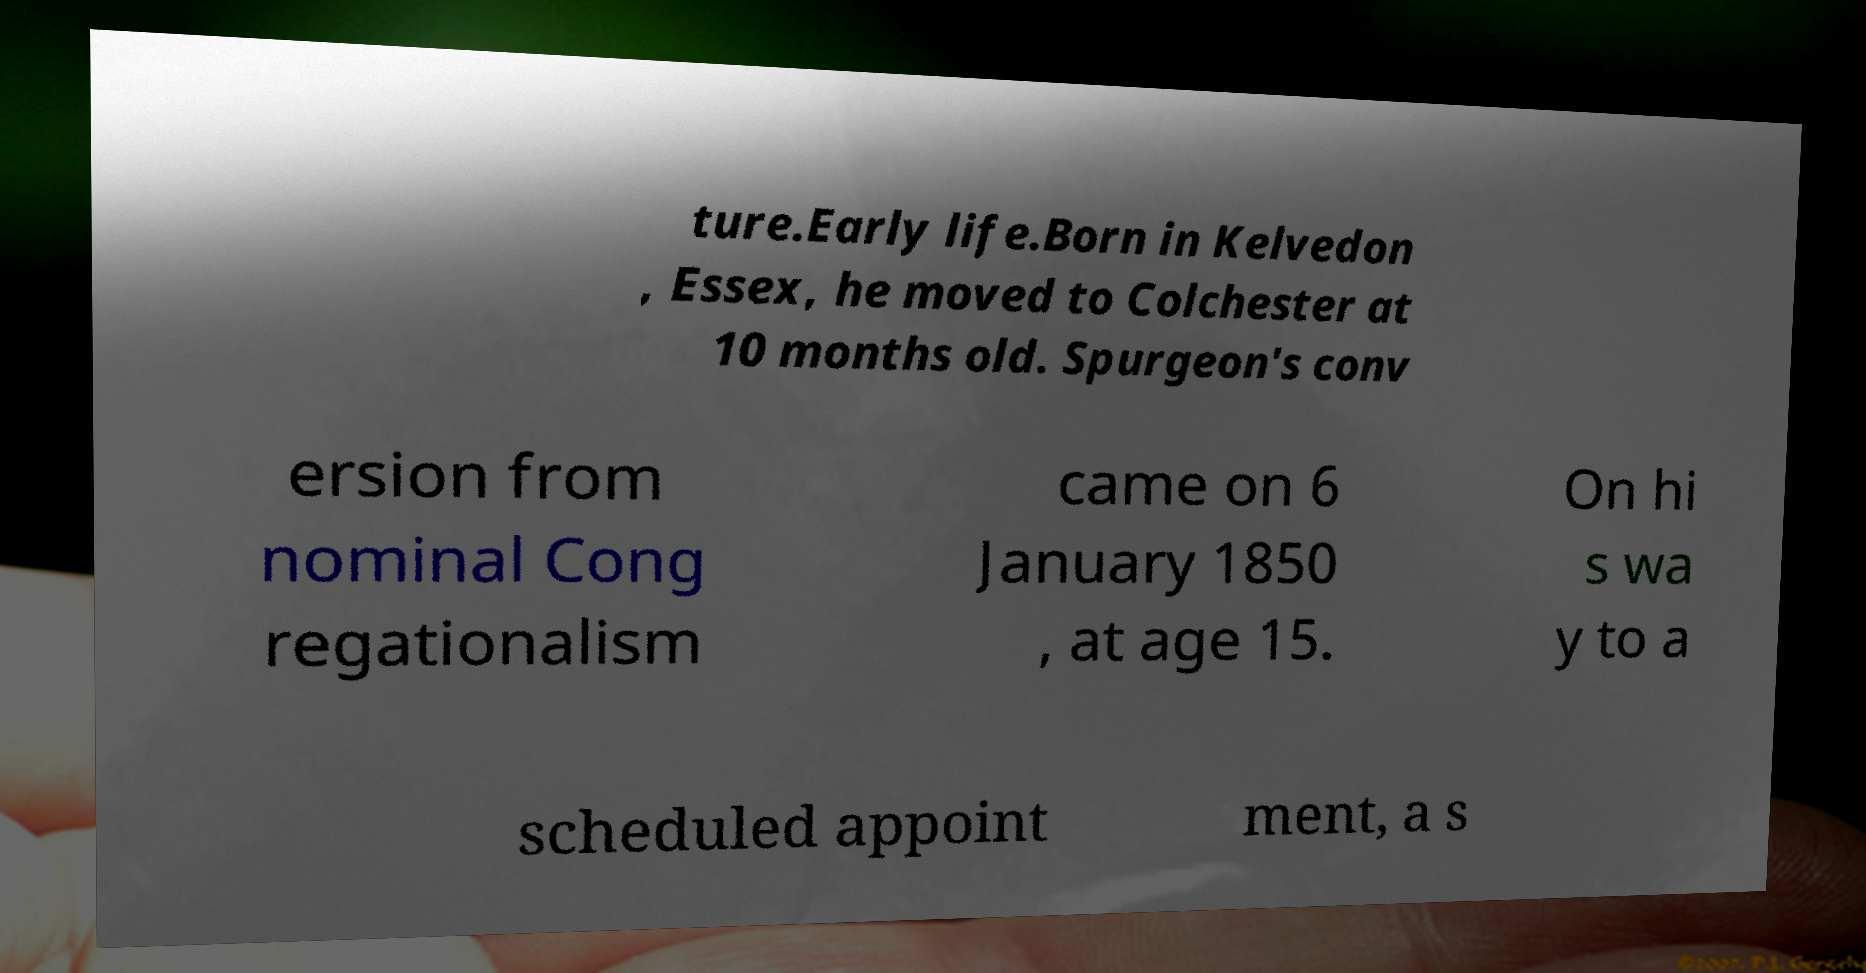Please identify and transcribe the text found in this image. ture.Early life.Born in Kelvedon , Essex, he moved to Colchester at 10 months old. Spurgeon's conv ersion from nominal Cong regationalism came on 6 January 1850 , at age 15. On hi s wa y to a scheduled appoint ment, a s 